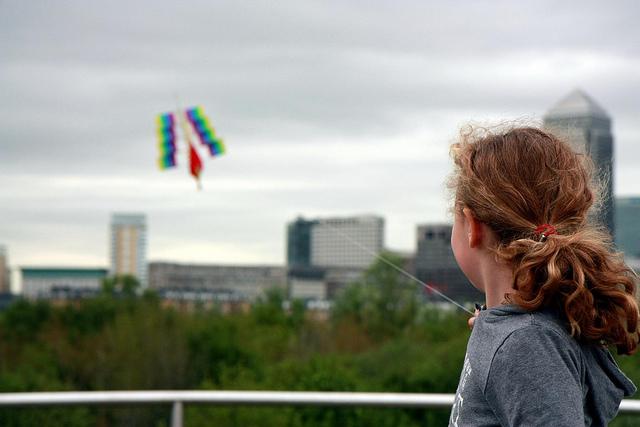Does the girl have long earrings?
Be succinct. No. How many hair items are in the girls hair?
Write a very short answer. 1. How many animals?
Write a very short answer. 0. What is in the air?
Write a very short answer. Kite. Is she a surfer?
Short answer required. No. Are the trees closer than the buildings?
Keep it brief. Yes. Is the woman wearing an earring?
Be succinct. No. What is in the air?
Write a very short answer. Kite. Is this a mirror?
Short answer required. No. What is the weather like?
Write a very short answer. Cloudy. What is that big green thing?
Short answer required. Kite. Is it a sunny day?
Give a very brief answer. No. What is the message on the shirt referencing?
Quick response, please. Love. What is she  holding?
Give a very brief answer. Kite. Is she wearing earrings?
Short answer required. No. What is the girl doing?
Answer briefly. Flying kite. 